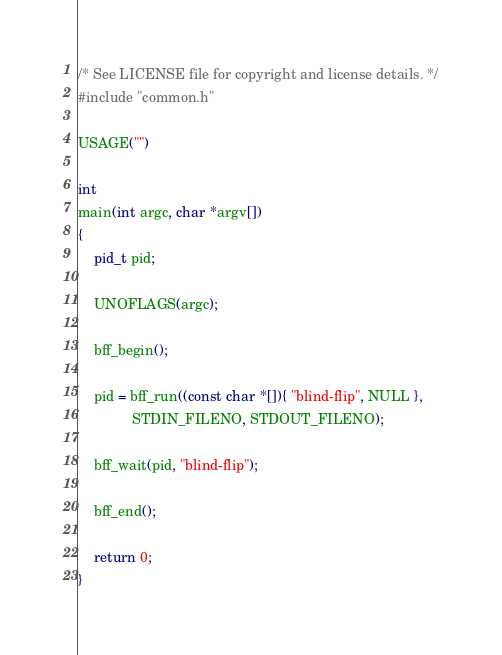Convert code to text. <code><loc_0><loc_0><loc_500><loc_500><_C_>/* See LICENSE file for copyright and license details. */
#include "common.h"

USAGE("")

int
main(int argc, char *argv[])
{
	pid_t pid;

	UNOFLAGS(argc);

	bff_begin();

	pid = bff_run((const char *[]){ "blind-flip", NULL },
		      STDIN_FILENO, STDOUT_FILENO);

	bff_wait(pid, "blind-flip");

	bff_end();

	return 0;
}
</code> 